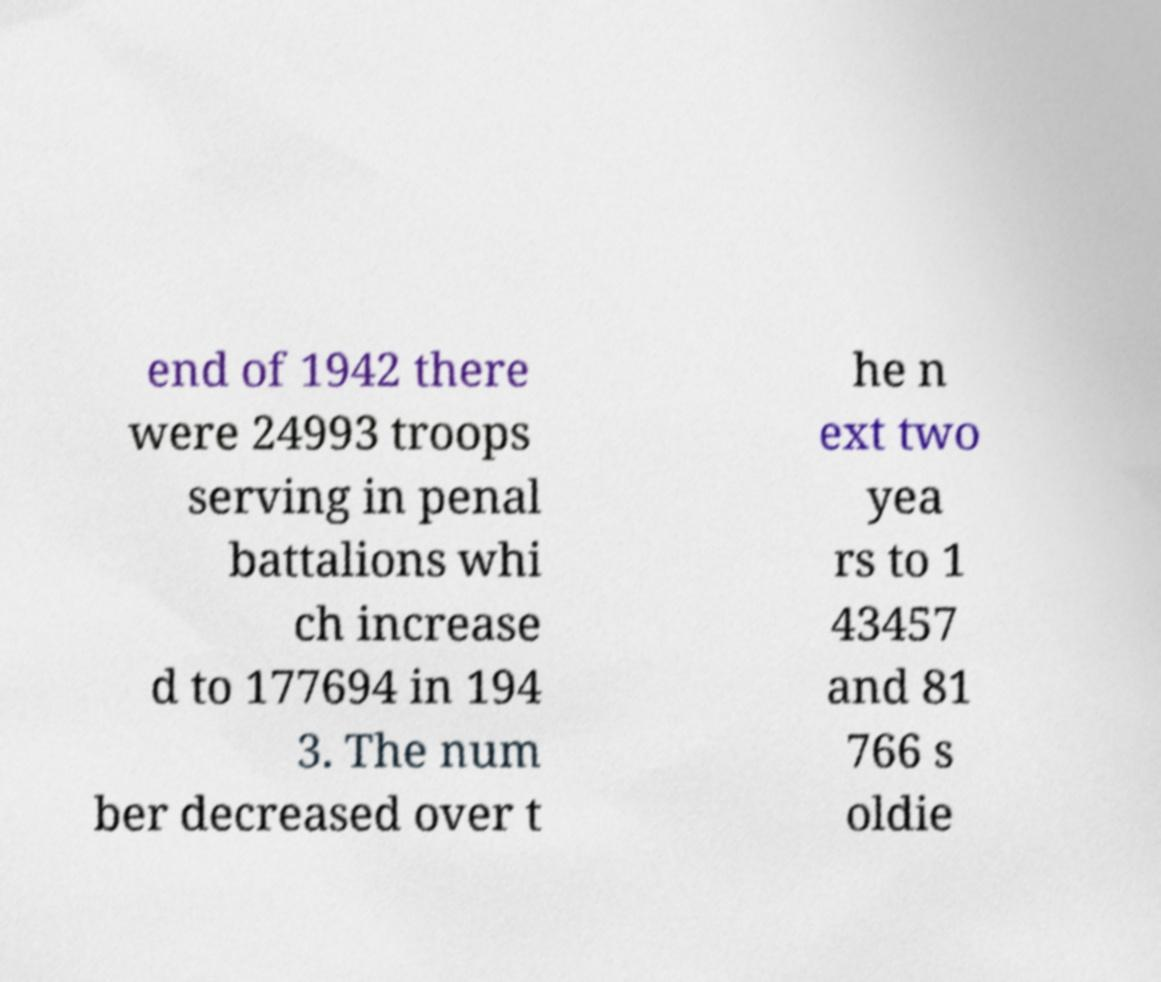Please identify and transcribe the text found in this image. end of 1942 there were 24993 troops serving in penal battalions whi ch increase d to 177694 in 194 3. The num ber decreased over t he n ext two yea rs to 1 43457 and 81 766 s oldie 